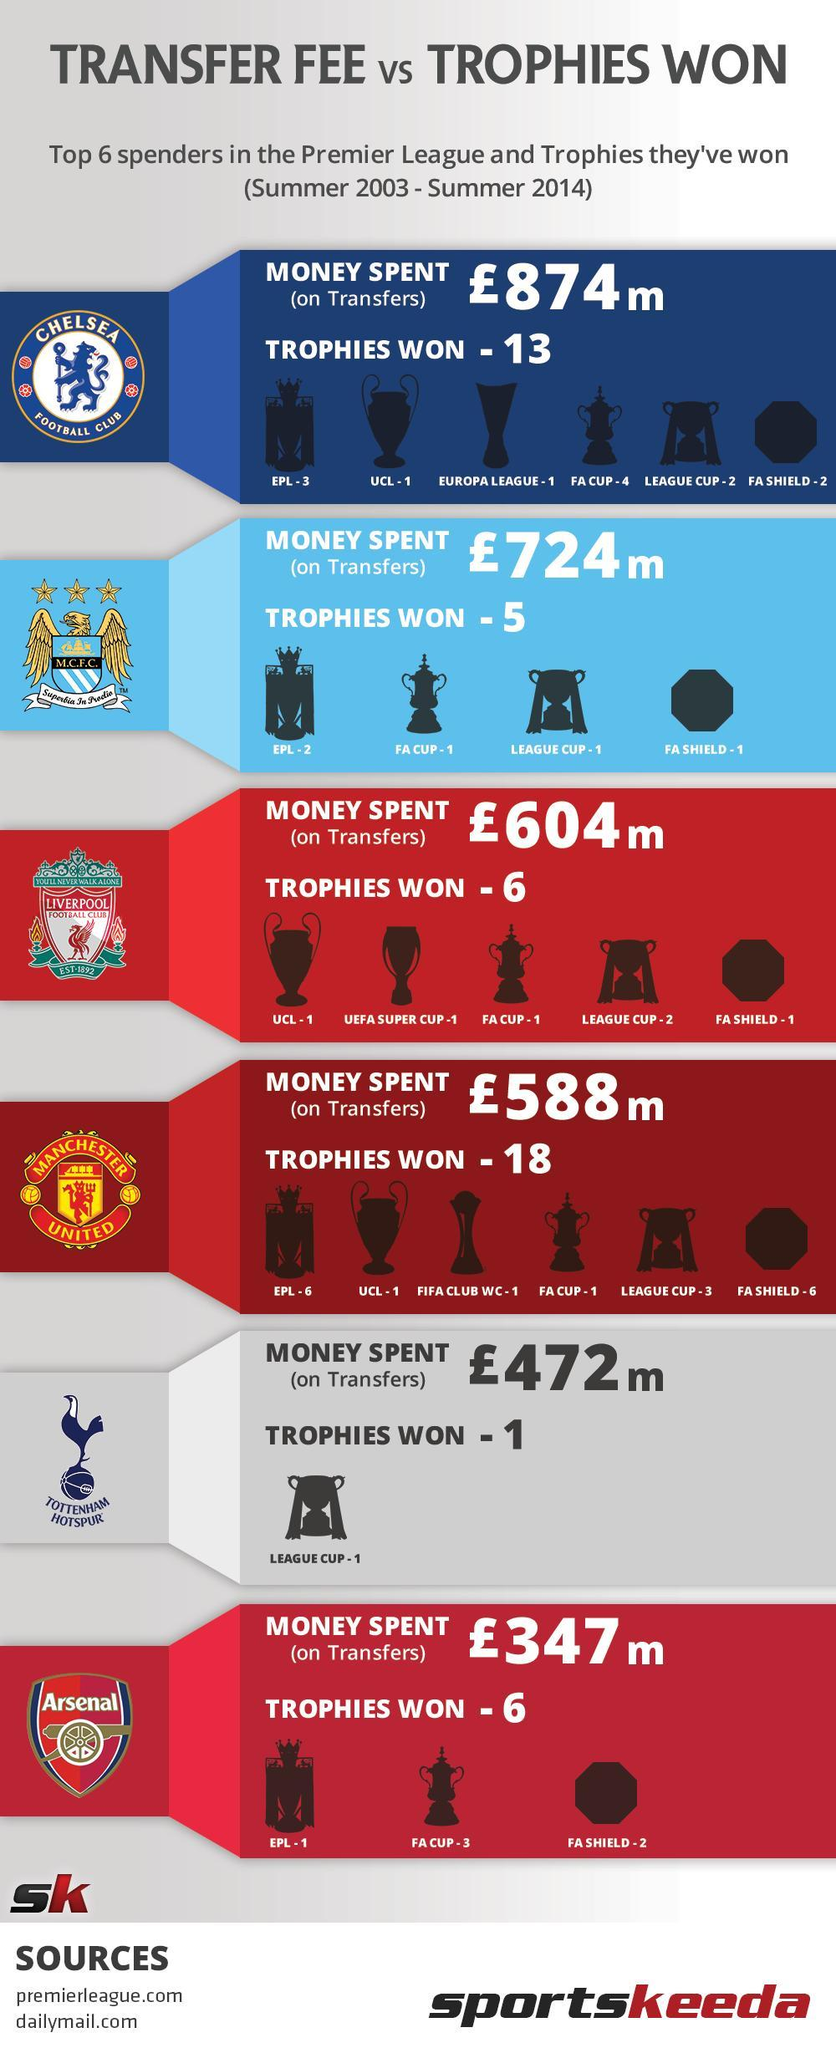How many trophies did Liverpool Football Club win in total in League Cup and FA Cup?
Answer the question with a short phrase. 3 Which team listed in the infographic have won the most trophies? Manchester United How many trophies did Manchester United win in League Cup and FA Cup? 4 How many trophies did Chelsea Football Club win in total in League Cup and FA Cup? 6 Which trophy did Tottenham Hotspur win? League Cup Which team listed in the infographic came in second in number of trophies they won? Chelsea Football Club How much more money on transfers did Chelsea football club spend more than M.C.F.C in Pounds? 150m How many trophies did Chelsea Football club win in FA Cup? 4 Which team listed in the infographic have won the least number of trophies? Tottenham Hotspur How many more trophies have Manchester United win compared to Chelsea Football Club? 5 